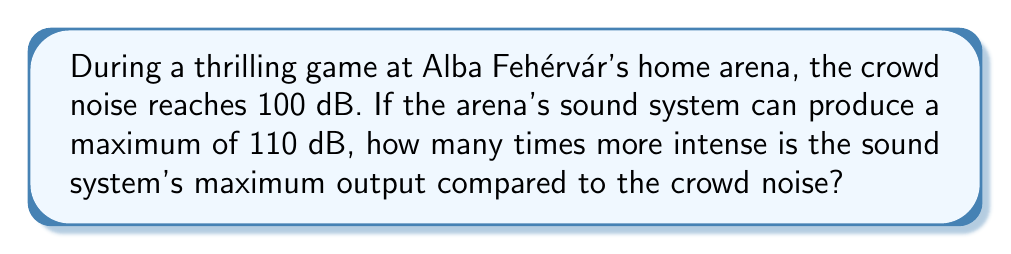Help me with this question. Let's approach this step-by-step using the logarithmic scale of decibels:

1) The decibel scale is logarithmic, based on the following equation:
   $$ L = 10 \log_{10}\left(\frac{I}{I_0}\right) $$
   Where $L$ is the sound level in decibels, $I$ is the sound intensity, and $I_0$ is a reference intensity.

2) We're comparing two intensities, so we can use the difference in decibels:
   $$ \Delta L = 10 \log_{10}\left(\frac{I_2}{I_1}\right) $$
   Where $\Delta L$ is the difference in decibel levels, $I_2$ is the higher intensity, and $I_1$ is the lower intensity.

3) In this case:
   $\Delta L = 110 \text{ dB} - 100 \text{ dB} = 10 \text{ dB}$

4) Plugging this into our equation:
   $$ 10 = 10 \log_{10}\left(\frac{I_2}{I_1}\right) $$

5) Simplifying:
   $$ 1 = \log_{10}\left(\frac{I_2}{I_1}\right) $$

6) Taking $10$ to the power of both sides:
   $$ 10^1 = \frac{I_2}{I_1} $$

7) Therefore:
   $$ \frac{I_2}{I_1} = 10 $$

This means the sound system's maximum output is 10 times more intense than the crowd noise.
Answer: 10 times 